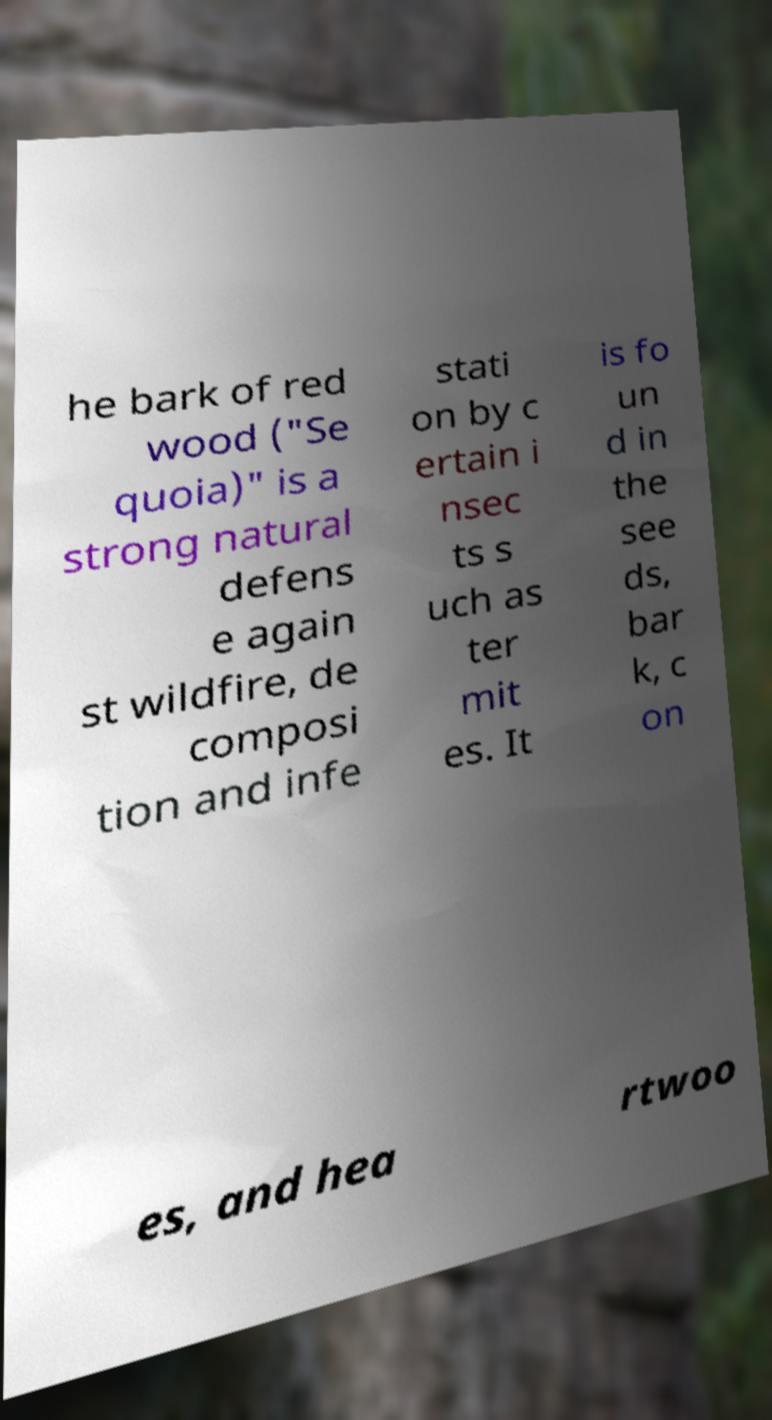Can you read and provide the text displayed in the image?This photo seems to have some interesting text. Can you extract and type it out for me? he bark of red wood ("Se quoia)" is a strong natural defens e again st wildfire, de composi tion and infe stati on by c ertain i nsec ts s uch as ter mit es. It is fo un d in the see ds, bar k, c on es, and hea rtwoo 